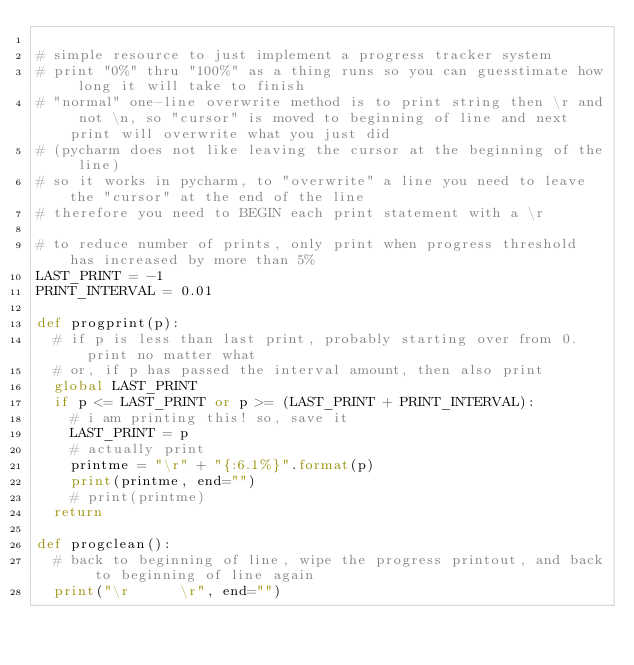Convert code to text. <code><loc_0><loc_0><loc_500><loc_500><_Python_>
# simple resource to just implement a progress tracker system
# print "0%" thru "100%" as a thing runs so you can guesstimate how long it will take to finish
# "normal" one-line overwrite method is to print string then \r and not \n, so "cursor" is moved to beginning of line and next print will overwrite what you just did
# (pycharm does not like leaving the cursor at the beginning of the line)
# so it works in pycharm, to "overwrite" a line you need to leave the "cursor" at the end of the line
# therefore you need to BEGIN each print statement with a \r

# to reduce number of prints, only print when progress threshold has increased by more than 5%
LAST_PRINT = -1
PRINT_INTERVAL = 0.01

def progprint(p):
	# if p is less than last print, probably starting over from 0. print no matter what
	# or, if p has passed the interval amount, then also print
	global LAST_PRINT
	if p <= LAST_PRINT or p >= (LAST_PRINT + PRINT_INTERVAL):
		# i am printing this! so, save it
		LAST_PRINT = p
		# actually print
		printme = "\r" + "{:6.1%}".format(p)
		print(printme, end="")
		# print(printme)
	return

def progclean():
	# back to beginning of line, wipe the progress printout, and back to beginning of line again
	print("\r      \r", end="")
	</code> 